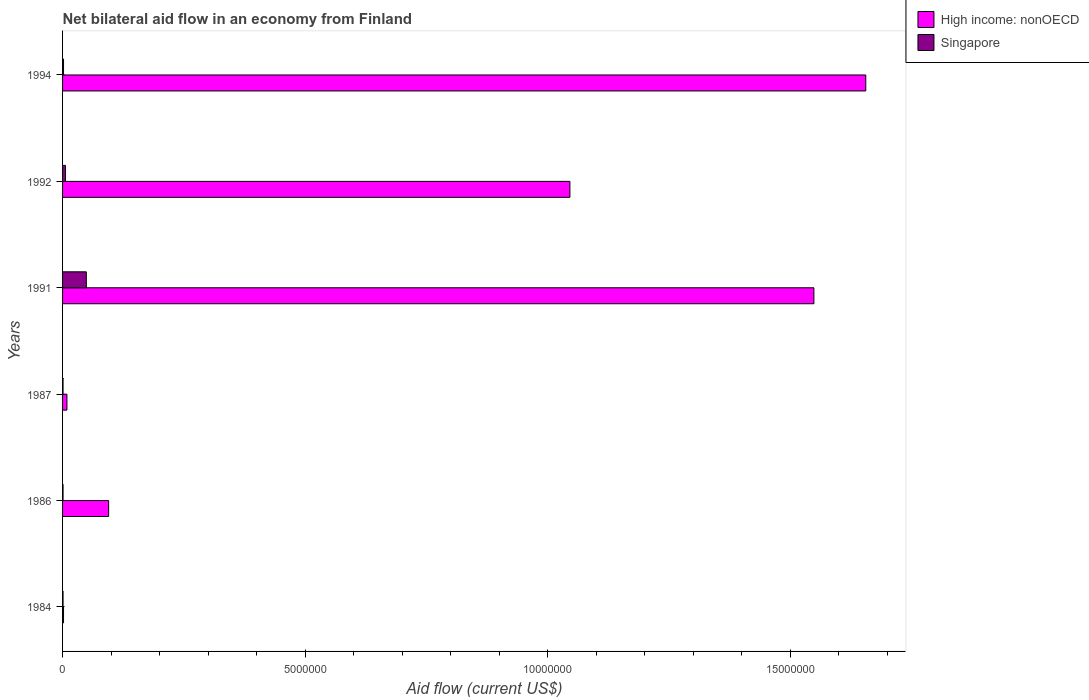How many groups of bars are there?
Your response must be concise. 6. How many bars are there on the 5th tick from the bottom?
Offer a very short reply. 2. What is the label of the 2nd group of bars from the top?
Provide a succinct answer. 1992. What is the net bilateral aid flow in Singapore in 1987?
Offer a terse response. 10000. Across all years, what is the maximum net bilateral aid flow in High income: nonOECD?
Give a very brief answer. 1.66e+07. Across all years, what is the minimum net bilateral aid flow in Singapore?
Give a very brief answer. 10000. In which year was the net bilateral aid flow in Singapore minimum?
Provide a succinct answer. 1984. What is the difference between the net bilateral aid flow in High income: nonOECD in 1987 and the net bilateral aid flow in Singapore in 1992?
Give a very brief answer. 3.00e+04. What is the average net bilateral aid flow in High income: nonOECD per year?
Your answer should be compact. 7.26e+06. In the year 1991, what is the difference between the net bilateral aid flow in Singapore and net bilateral aid flow in High income: nonOECD?
Your answer should be compact. -1.50e+07. What is the ratio of the net bilateral aid flow in High income: nonOECD in 1984 to that in 1992?
Offer a terse response. 0. Is the net bilateral aid flow in Singapore in 1984 less than that in 1992?
Ensure brevity in your answer.  Yes. Is the difference between the net bilateral aid flow in Singapore in 1991 and 1992 greater than the difference between the net bilateral aid flow in High income: nonOECD in 1991 and 1992?
Offer a very short reply. No. What is the difference between the highest and the lowest net bilateral aid flow in Singapore?
Provide a short and direct response. 4.80e+05. In how many years, is the net bilateral aid flow in Singapore greater than the average net bilateral aid flow in Singapore taken over all years?
Your answer should be very brief. 1. Is the sum of the net bilateral aid flow in Singapore in 1984 and 1987 greater than the maximum net bilateral aid flow in High income: nonOECD across all years?
Provide a succinct answer. No. What does the 1st bar from the top in 1994 represents?
Provide a succinct answer. Singapore. What does the 2nd bar from the bottom in 1986 represents?
Offer a terse response. Singapore. How many years are there in the graph?
Keep it short and to the point. 6. Where does the legend appear in the graph?
Give a very brief answer. Top right. How many legend labels are there?
Your response must be concise. 2. How are the legend labels stacked?
Offer a terse response. Vertical. What is the title of the graph?
Make the answer very short. Net bilateral aid flow in an economy from Finland. What is the Aid flow (current US$) in Singapore in 1984?
Keep it short and to the point. 10000. What is the Aid flow (current US$) in High income: nonOECD in 1986?
Ensure brevity in your answer.  9.50e+05. What is the Aid flow (current US$) in High income: nonOECD in 1987?
Your response must be concise. 9.00e+04. What is the Aid flow (current US$) in Singapore in 1987?
Give a very brief answer. 10000. What is the Aid flow (current US$) of High income: nonOECD in 1991?
Provide a succinct answer. 1.55e+07. What is the Aid flow (current US$) in Singapore in 1991?
Keep it short and to the point. 4.90e+05. What is the Aid flow (current US$) in High income: nonOECD in 1992?
Keep it short and to the point. 1.05e+07. What is the Aid flow (current US$) in High income: nonOECD in 1994?
Give a very brief answer. 1.66e+07. What is the Aid flow (current US$) of Singapore in 1994?
Give a very brief answer. 2.00e+04. Across all years, what is the maximum Aid flow (current US$) of High income: nonOECD?
Provide a short and direct response. 1.66e+07. Across all years, what is the minimum Aid flow (current US$) of High income: nonOECD?
Ensure brevity in your answer.  2.00e+04. Across all years, what is the minimum Aid flow (current US$) of Singapore?
Provide a succinct answer. 10000. What is the total Aid flow (current US$) in High income: nonOECD in the graph?
Your response must be concise. 4.36e+07. What is the total Aid flow (current US$) in Singapore in the graph?
Provide a short and direct response. 6.00e+05. What is the difference between the Aid flow (current US$) of High income: nonOECD in 1984 and that in 1986?
Offer a terse response. -9.30e+05. What is the difference between the Aid flow (current US$) of High income: nonOECD in 1984 and that in 1987?
Make the answer very short. -7.00e+04. What is the difference between the Aid flow (current US$) of High income: nonOECD in 1984 and that in 1991?
Provide a succinct answer. -1.55e+07. What is the difference between the Aid flow (current US$) of Singapore in 1984 and that in 1991?
Ensure brevity in your answer.  -4.80e+05. What is the difference between the Aid flow (current US$) in High income: nonOECD in 1984 and that in 1992?
Provide a short and direct response. -1.04e+07. What is the difference between the Aid flow (current US$) of High income: nonOECD in 1984 and that in 1994?
Offer a very short reply. -1.65e+07. What is the difference between the Aid flow (current US$) in Singapore in 1984 and that in 1994?
Keep it short and to the point. -10000. What is the difference between the Aid flow (current US$) in High income: nonOECD in 1986 and that in 1987?
Keep it short and to the point. 8.60e+05. What is the difference between the Aid flow (current US$) in Singapore in 1986 and that in 1987?
Keep it short and to the point. 0. What is the difference between the Aid flow (current US$) of High income: nonOECD in 1986 and that in 1991?
Offer a very short reply. -1.45e+07. What is the difference between the Aid flow (current US$) in Singapore in 1986 and that in 1991?
Make the answer very short. -4.80e+05. What is the difference between the Aid flow (current US$) in High income: nonOECD in 1986 and that in 1992?
Ensure brevity in your answer.  -9.51e+06. What is the difference between the Aid flow (current US$) in Singapore in 1986 and that in 1992?
Make the answer very short. -5.00e+04. What is the difference between the Aid flow (current US$) in High income: nonOECD in 1986 and that in 1994?
Ensure brevity in your answer.  -1.56e+07. What is the difference between the Aid flow (current US$) in High income: nonOECD in 1987 and that in 1991?
Your answer should be compact. -1.54e+07. What is the difference between the Aid flow (current US$) in Singapore in 1987 and that in 1991?
Offer a very short reply. -4.80e+05. What is the difference between the Aid flow (current US$) in High income: nonOECD in 1987 and that in 1992?
Your answer should be compact. -1.04e+07. What is the difference between the Aid flow (current US$) in Singapore in 1987 and that in 1992?
Give a very brief answer. -5.00e+04. What is the difference between the Aid flow (current US$) of High income: nonOECD in 1987 and that in 1994?
Your answer should be compact. -1.65e+07. What is the difference between the Aid flow (current US$) in High income: nonOECD in 1991 and that in 1992?
Your answer should be very brief. 5.03e+06. What is the difference between the Aid flow (current US$) of Singapore in 1991 and that in 1992?
Offer a very short reply. 4.30e+05. What is the difference between the Aid flow (current US$) in High income: nonOECD in 1991 and that in 1994?
Give a very brief answer. -1.07e+06. What is the difference between the Aid flow (current US$) in High income: nonOECD in 1992 and that in 1994?
Give a very brief answer. -6.10e+06. What is the difference between the Aid flow (current US$) in Singapore in 1992 and that in 1994?
Give a very brief answer. 4.00e+04. What is the difference between the Aid flow (current US$) in High income: nonOECD in 1984 and the Aid flow (current US$) in Singapore in 1986?
Provide a succinct answer. 10000. What is the difference between the Aid flow (current US$) of High income: nonOECD in 1984 and the Aid flow (current US$) of Singapore in 1987?
Keep it short and to the point. 10000. What is the difference between the Aid flow (current US$) of High income: nonOECD in 1984 and the Aid flow (current US$) of Singapore in 1991?
Your answer should be compact. -4.70e+05. What is the difference between the Aid flow (current US$) of High income: nonOECD in 1984 and the Aid flow (current US$) of Singapore in 1992?
Make the answer very short. -4.00e+04. What is the difference between the Aid flow (current US$) in High income: nonOECD in 1986 and the Aid flow (current US$) in Singapore in 1987?
Offer a very short reply. 9.40e+05. What is the difference between the Aid flow (current US$) of High income: nonOECD in 1986 and the Aid flow (current US$) of Singapore in 1991?
Provide a succinct answer. 4.60e+05. What is the difference between the Aid flow (current US$) in High income: nonOECD in 1986 and the Aid flow (current US$) in Singapore in 1992?
Provide a succinct answer. 8.90e+05. What is the difference between the Aid flow (current US$) in High income: nonOECD in 1986 and the Aid flow (current US$) in Singapore in 1994?
Your response must be concise. 9.30e+05. What is the difference between the Aid flow (current US$) of High income: nonOECD in 1987 and the Aid flow (current US$) of Singapore in 1991?
Offer a terse response. -4.00e+05. What is the difference between the Aid flow (current US$) of High income: nonOECD in 1987 and the Aid flow (current US$) of Singapore in 1994?
Provide a succinct answer. 7.00e+04. What is the difference between the Aid flow (current US$) in High income: nonOECD in 1991 and the Aid flow (current US$) in Singapore in 1992?
Ensure brevity in your answer.  1.54e+07. What is the difference between the Aid flow (current US$) in High income: nonOECD in 1991 and the Aid flow (current US$) in Singapore in 1994?
Provide a short and direct response. 1.55e+07. What is the difference between the Aid flow (current US$) of High income: nonOECD in 1992 and the Aid flow (current US$) of Singapore in 1994?
Keep it short and to the point. 1.04e+07. What is the average Aid flow (current US$) in High income: nonOECD per year?
Provide a short and direct response. 7.26e+06. In the year 1984, what is the difference between the Aid flow (current US$) of High income: nonOECD and Aid flow (current US$) of Singapore?
Ensure brevity in your answer.  10000. In the year 1986, what is the difference between the Aid flow (current US$) in High income: nonOECD and Aid flow (current US$) in Singapore?
Ensure brevity in your answer.  9.40e+05. In the year 1987, what is the difference between the Aid flow (current US$) in High income: nonOECD and Aid flow (current US$) in Singapore?
Make the answer very short. 8.00e+04. In the year 1991, what is the difference between the Aid flow (current US$) of High income: nonOECD and Aid flow (current US$) of Singapore?
Give a very brief answer. 1.50e+07. In the year 1992, what is the difference between the Aid flow (current US$) in High income: nonOECD and Aid flow (current US$) in Singapore?
Ensure brevity in your answer.  1.04e+07. In the year 1994, what is the difference between the Aid flow (current US$) of High income: nonOECD and Aid flow (current US$) of Singapore?
Your answer should be compact. 1.65e+07. What is the ratio of the Aid flow (current US$) of High income: nonOECD in 1984 to that in 1986?
Your answer should be very brief. 0.02. What is the ratio of the Aid flow (current US$) in High income: nonOECD in 1984 to that in 1987?
Provide a short and direct response. 0.22. What is the ratio of the Aid flow (current US$) of Singapore in 1984 to that in 1987?
Offer a terse response. 1. What is the ratio of the Aid flow (current US$) in High income: nonOECD in 1984 to that in 1991?
Your answer should be very brief. 0. What is the ratio of the Aid flow (current US$) of Singapore in 1984 to that in 1991?
Provide a short and direct response. 0.02. What is the ratio of the Aid flow (current US$) of High income: nonOECD in 1984 to that in 1992?
Ensure brevity in your answer.  0. What is the ratio of the Aid flow (current US$) of Singapore in 1984 to that in 1992?
Offer a very short reply. 0.17. What is the ratio of the Aid flow (current US$) in High income: nonOECD in 1984 to that in 1994?
Provide a succinct answer. 0. What is the ratio of the Aid flow (current US$) in High income: nonOECD in 1986 to that in 1987?
Give a very brief answer. 10.56. What is the ratio of the Aid flow (current US$) in Singapore in 1986 to that in 1987?
Your response must be concise. 1. What is the ratio of the Aid flow (current US$) of High income: nonOECD in 1986 to that in 1991?
Your response must be concise. 0.06. What is the ratio of the Aid flow (current US$) of Singapore in 1986 to that in 1991?
Ensure brevity in your answer.  0.02. What is the ratio of the Aid flow (current US$) of High income: nonOECD in 1986 to that in 1992?
Provide a short and direct response. 0.09. What is the ratio of the Aid flow (current US$) in Singapore in 1986 to that in 1992?
Provide a short and direct response. 0.17. What is the ratio of the Aid flow (current US$) in High income: nonOECD in 1986 to that in 1994?
Provide a short and direct response. 0.06. What is the ratio of the Aid flow (current US$) of Singapore in 1986 to that in 1994?
Make the answer very short. 0.5. What is the ratio of the Aid flow (current US$) of High income: nonOECD in 1987 to that in 1991?
Give a very brief answer. 0.01. What is the ratio of the Aid flow (current US$) of Singapore in 1987 to that in 1991?
Keep it short and to the point. 0.02. What is the ratio of the Aid flow (current US$) of High income: nonOECD in 1987 to that in 1992?
Offer a terse response. 0.01. What is the ratio of the Aid flow (current US$) in High income: nonOECD in 1987 to that in 1994?
Your response must be concise. 0.01. What is the ratio of the Aid flow (current US$) of Singapore in 1987 to that in 1994?
Provide a succinct answer. 0.5. What is the ratio of the Aid flow (current US$) of High income: nonOECD in 1991 to that in 1992?
Keep it short and to the point. 1.48. What is the ratio of the Aid flow (current US$) of Singapore in 1991 to that in 1992?
Your response must be concise. 8.17. What is the ratio of the Aid flow (current US$) of High income: nonOECD in 1991 to that in 1994?
Offer a terse response. 0.94. What is the ratio of the Aid flow (current US$) in Singapore in 1991 to that in 1994?
Provide a short and direct response. 24.5. What is the ratio of the Aid flow (current US$) of High income: nonOECD in 1992 to that in 1994?
Your answer should be compact. 0.63. What is the difference between the highest and the second highest Aid flow (current US$) in High income: nonOECD?
Provide a short and direct response. 1.07e+06. What is the difference between the highest and the second highest Aid flow (current US$) in Singapore?
Your answer should be very brief. 4.30e+05. What is the difference between the highest and the lowest Aid flow (current US$) in High income: nonOECD?
Your response must be concise. 1.65e+07. What is the difference between the highest and the lowest Aid flow (current US$) in Singapore?
Keep it short and to the point. 4.80e+05. 